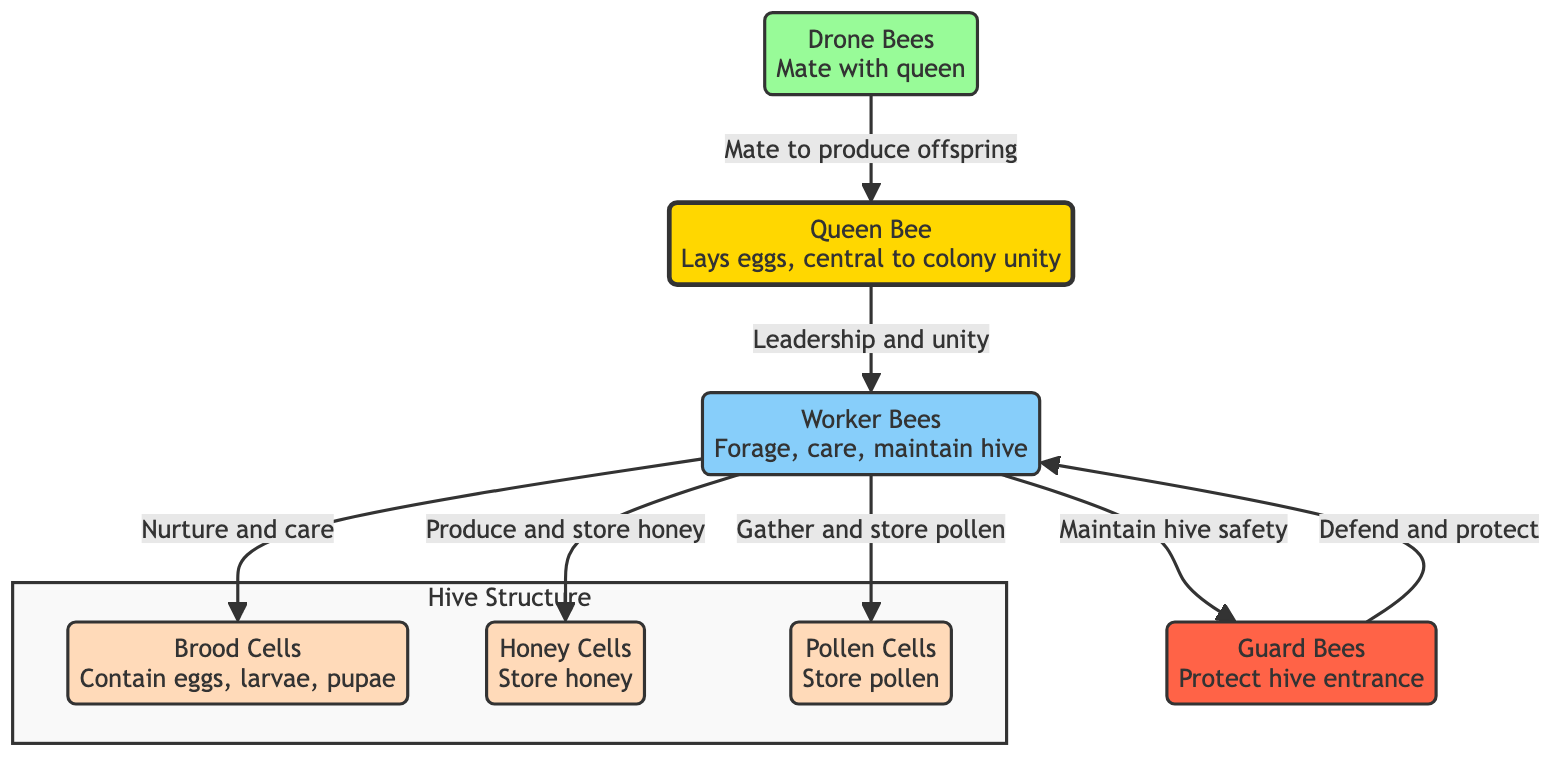What's the primary role of the Queen Bee? The diagram indicates that the Queen Bee lays eggs and is central to colony unity. This identifies her as the key reproductive figure in the hive, emphasizing her role in maintaining the group's cohesiveness.
Answer: Lays eggs How many types of bees are shown in the diagram? By examining the diagram, we can count the distinct types of bees labeled: the Queen Bee, Worker Bees, Drone Bees, and Guard Bees. This gives us a straightforward count of the unique roles represented.
Answer: Four What do Worker Bees do with Honey Cells? The diagram describes that Worker Bees produce and store honey in Honey Cells, showing their responsibility for this crucial resource within the hive.
Answer: Produce and store honey Which bees defend and protect the hive? The diagram clearly illustrates Guard Bees as the specific type of bee responsible for protecting the hive entrance, highlighting their defensive role in the colony's safety.
Answer: Guard Bees What is the relationship between Drone Bees and the Queen Bee? The diagram shows an arrow pointing from Drone Bees to the Queen Bee labeled "Mate to produce offspring." This signals their reproductive function in the colony's life cycle.
Answer: Mate How do Worker Bees contribute to nurturing the Brood Cells? There is a direct arrow from Worker Bees to Brood Cells labeled "Nurture and care," indicating that Worker Bees are actively involved in the care of the hive's young.
Answer: Nurture and care What do Pollen Cells store? The diagram labels Pollen Cells specifically for storing pollen, showing their role as a storage area for this essential nutrient.
Answer: Store pollen Which group is responsible for maintaining hive safety? The relationship in the diagram captures that Worker Bees maintain hive safety, evident from their direct connection to Guard Bees, who manage the hive's security.
Answer: Worker Bees What is the purpose of the Brood Cells as depicted in the diagram? The diagram clearly states that Brood Cells contain eggs, larvae, and pupae, illustrating their role in the colony's reproductive cycle and development of new bees.
Answer: Contain eggs, larvae, pupae 